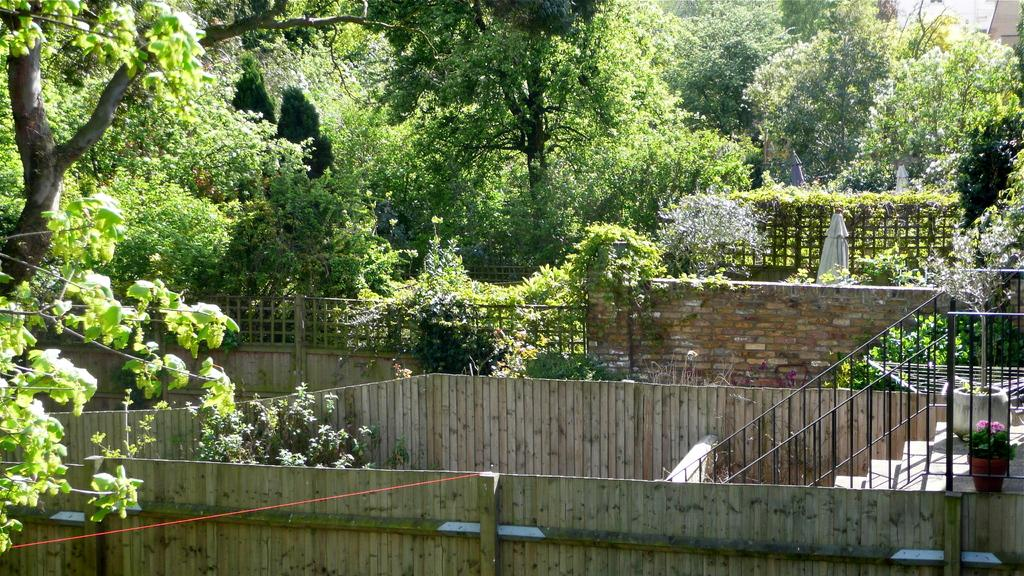What type of outdoor space is depicted in the image? The image contains a garden. What natural elements can be seen in the garden? There are trees and plants in the garden. Are there any architectural features in the garden? Yes, there is a staircase, a fence, and a wall in the garden. What additional object can be found in the garden? There is a rope in the garden. Can you tell me where the zebra is standing in the garden? There is no zebra present in the image; it only features a garden with trees, plants, a staircase, a rope, a fence, and a wall. Who is taking the picture of the garden? The image does not show a camera or a person taking a picture, so it is not possible to determine who might be taking the picture. 